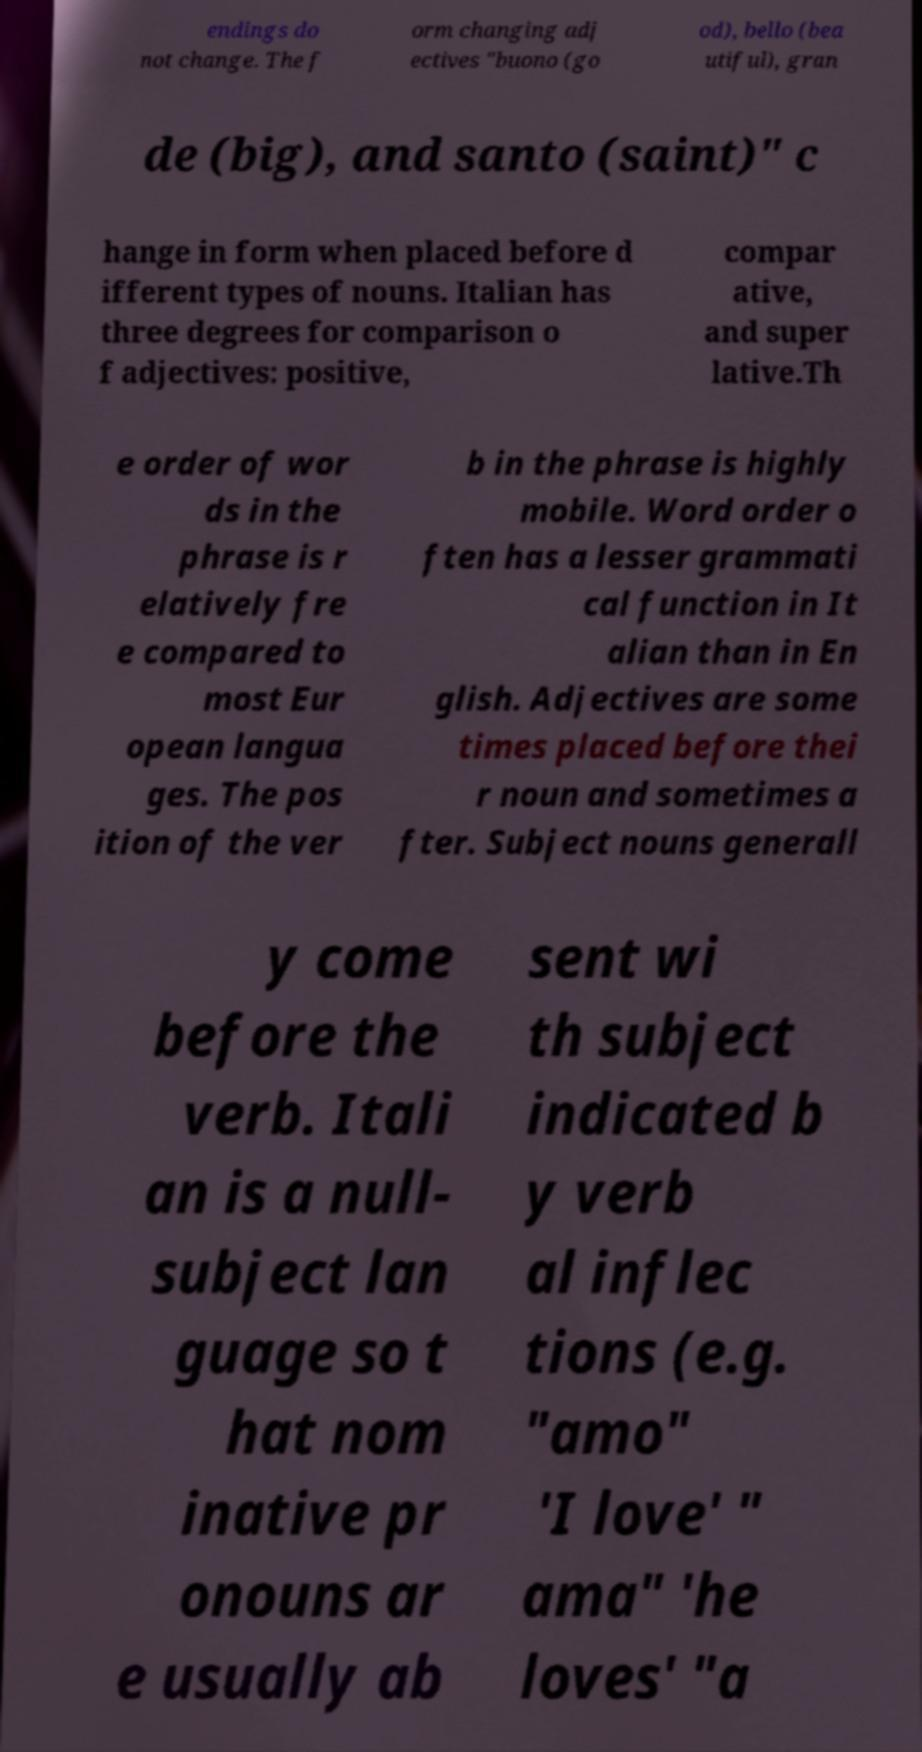For documentation purposes, I need the text within this image transcribed. Could you provide that? endings do not change. The f orm changing adj ectives "buono (go od), bello (bea utiful), gran de (big), and santo (saint)" c hange in form when placed before d ifferent types of nouns. Italian has three degrees for comparison o f adjectives: positive, compar ative, and super lative.Th e order of wor ds in the phrase is r elatively fre e compared to most Eur opean langua ges. The pos ition of the ver b in the phrase is highly mobile. Word order o ften has a lesser grammati cal function in It alian than in En glish. Adjectives are some times placed before thei r noun and sometimes a fter. Subject nouns generall y come before the verb. Itali an is a null- subject lan guage so t hat nom inative pr onouns ar e usually ab sent wi th subject indicated b y verb al inflec tions (e.g. "amo" 'I love' " ama" 'he loves' "a 